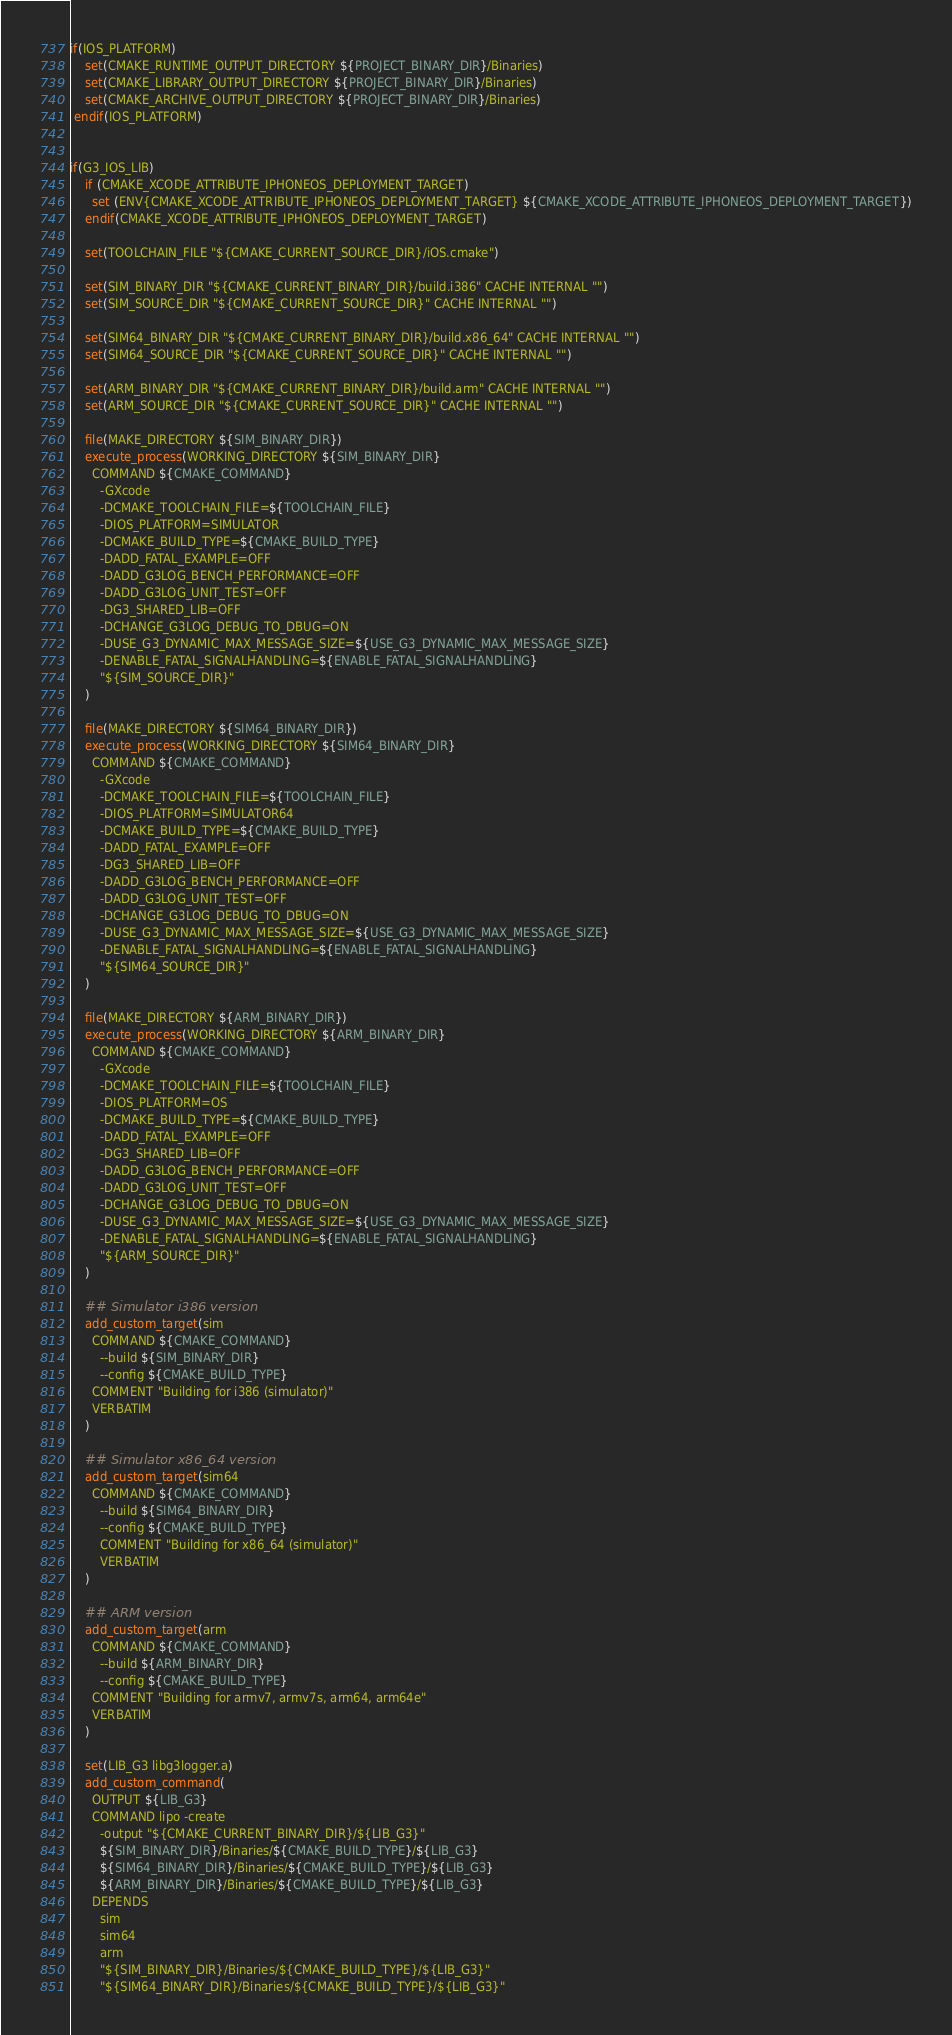Convert code to text. <code><loc_0><loc_0><loc_500><loc_500><_CMake_>if(IOS_PLATFORM)
    set(CMAKE_RUNTIME_OUTPUT_DIRECTORY ${PROJECT_BINARY_DIR}/Binaries)
    set(CMAKE_LIBRARY_OUTPUT_DIRECTORY ${PROJECT_BINARY_DIR}/Binaries)
    set(CMAKE_ARCHIVE_OUTPUT_DIRECTORY ${PROJECT_BINARY_DIR}/Binaries)
 endif(IOS_PLATFORM)


if(G3_IOS_LIB)
	if (CMAKE_XCODE_ATTRIBUTE_IPHONEOS_DEPLOYMENT_TARGET)
	  set (ENV{CMAKE_XCODE_ATTRIBUTE_IPHONEOS_DEPLOYMENT_TARGET} ${CMAKE_XCODE_ATTRIBUTE_IPHONEOS_DEPLOYMENT_TARGET})
	endif(CMAKE_XCODE_ATTRIBUTE_IPHONEOS_DEPLOYMENT_TARGET)

	set(TOOLCHAIN_FILE "${CMAKE_CURRENT_SOURCE_DIR}/iOS.cmake")

	set(SIM_BINARY_DIR "${CMAKE_CURRENT_BINARY_DIR}/build.i386" CACHE INTERNAL "")
	set(SIM_SOURCE_DIR "${CMAKE_CURRENT_SOURCE_DIR}" CACHE INTERNAL "")

	set(SIM64_BINARY_DIR "${CMAKE_CURRENT_BINARY_DIR}/build.x86_64" CACHE INTERNAL "")
	set(SIM64_SOURCE_DIR "${CMAKE_CURRENT_SOURCE_DIR}" CACHE INTERNAL "")

	set(ARM_BINARY_DIR "${CMAKE_CURRENT_BINARY_DIR}/build.arm" CACHE INTERNAL "")
	set(ARM_SOURCE_DIR "${CMAKE_CURRENT_SOURCE_DIR}" CACHE INTERNAL "")

	file(MAKE_DIRECTORY ${SIM_BINARY_DIR})
	execute_process(WORKING_DIRECTORY ${SIM_BINARY_DIR}
	  COMMAND ${CMAKE_COMMAND}
    	-GXcode
	    -DCMAKE_TOOLCHAIN_FILE=${TOOLCHAIN_FILE}
	    -DIOS_PLATFORM=SIMULATOR
	    -DCMAKE_BUILD_TYPE=${CMAKE_BUILD_TYPE}
		-DADD_FATAL_EXAMPLE=OFF
		-DADD_G3LOG_BENCH_PERFORMANCE=OFF
		-DADD_G3LOG_UNIT_TEST=OFF
	    -DG3_SHARED_LIB=OFF
	    -DCHANGE_G3LOG_DEBUG_TO_DBUG=ON
	    -DUSE_G3_DYNAMIC_MAX_MESSAGE_SIZE=${USE_G3_DYNAMIC_MAX_MESSAGE_SIZE}
	    -DENABLE_FATAL_SIGNALHANDLING=${ENABLE_FATAL_SIGNALHANDLING}
	    "${SIM_SOURCE_DIR}"
    )

	file(MAKE_DIRECTORY ${SIM64_BINARY_DIR})
	execute_process(WORKING_DIRECTORY ${SIM64_BINARY_DIR}
	  COMMAND ${CMAKE_COMMAND}
	    -GXcode
	    -DCMAKE_TOOLCHAIN_FILE=${TOOLCHAIN_FILE}
	    -DIOS_PLATFORM=SIMULATOR64
	    -DCMAKE_BUILD_TYPE=${CMAKE_BUILD_TYPE}
		-DADD_FATAL_EXAMPLE=OFF
	    -DG3_SHARED_LIB=OFF
		-DADD_G3LOG_BENCH_PERFORMANCE=OFF
		-DADD_G3LOG_UNIT_TEST=OFF
	    -DCHANGE_G3LOG_DEBUG_TO_DBUG=ON
	    -DUSE_G3_DYNAMIC_MAX_MESSAGE_SIZE=${USE_G3_DYNAMIC_MAX_MESSAGE_SIZE}
	    -DENABLE_FATAL_SIGNALHANDLING=${ENABLE_FATAL_SIGNALHANDLING}
	    "${SIM64_SOURCE_DIR}"
	)

	file(MAKE_DIRECTORY ${ARM_BINARY_DIR})
	execute_process(WORKING_DIRECTORY ${ARM_BINARY_DIR}
	  COMMAND ${CMAKE_COMMAND}
	    -GXcode
	    -DCMAKE_TOOLCHAIN_FILE=${TOOLCHAIN_FILE}
	    -DIOS_PLATFORM=OS
	    -DCMAKE_BUILD_TYPE=${CMAKE_BUILD_TYPE}
		-DADD_FATAL_EXAMPLE=OFF
	    -DG3_SHARED_LIB=OFF
		-DADD_G3LOG_BENCH_PERFORMANCE=OFF
		-DADD_G3LOG_UNIT_TEST=OFF
	    -DCHANGE_G3LOG_DEBUG_TO_DBUG=ON
	    -DUSE_G3_DYNAMIC_MAX_MESSAGE_SIZE=${USE_G3_DYNAMIC_MAX_MESSAGE_SIZE}
	    -DENABLE_FATAL_SIGNALHANDLING=${ENABLE_FATAL_SIGNALHANDLING}
	    "${ARM_SOURCE_DIR}"
    )

	## Simulator i386 version
	add_custom_target(sim
	  COMMAND ${CMAKE_COMMAND}
	    --build ${SIM_BINARY_DIR}
	    --config ${CMAKE_BUILD_TYPE}
	  COMMENT "Building for i386 (simulator)"
	  VERBATIM
	)

	## Simulator x86_64 version
	add_custom_target(sim64
	  COMMAND ${CMAKE_COMMAND}
	    --build ${SIM64_BINARY_DIR}
	    --config ${CMAKE_BUILD_TYPE}
	    COMMENT "Building for x86_64 (simulator)"
		VERBATIM
	)

	## ARM version
	add_custom_target(arm
	  COMMAND ${CMAKE_COMMAND}
	    --build ${ARM_BINARY_DIR}
	    --config ${CMAKE_BUILD_TYPE}
	  COMMENT "Building for armv7, armv7s, arm64, arm64e"
	  VERBATIM
	)

	set(LIB_G3 libg3logger.a)
	add_custom_command(
	  OUTPUT ${LIB_G3}
	  COMMAND lipo -create
	    -output "${CMAKE_CURRENT_BINARY_DIR}/${LIB_G3}"
	    ${SIM_BINARY_DIR}/Binaries/${CMAKE_BUILD_TYPE}/${LIB_G3}
	    ${SIM64_BINARY_DIR}/Binaries/${CMAKE_BUILD_TYPE}/${LIB_G3}
	    ${ARM_BINARY_DIR}/Binaries/${CMAKE_BUILD_TYPE}/${LIB_G3}
	  DEPENDS
	    sim
	    sim64
	    arm
	    "${SIM_BINARY_DIR}/Binaries/${CMAKE_BUILD_TYPE}/${LIB_G3}"
	    "${SIM64_BINARY_DIR}/Binaries/${CMAKE_BUILD_TYPE}/${LIB_G3}"</code> 